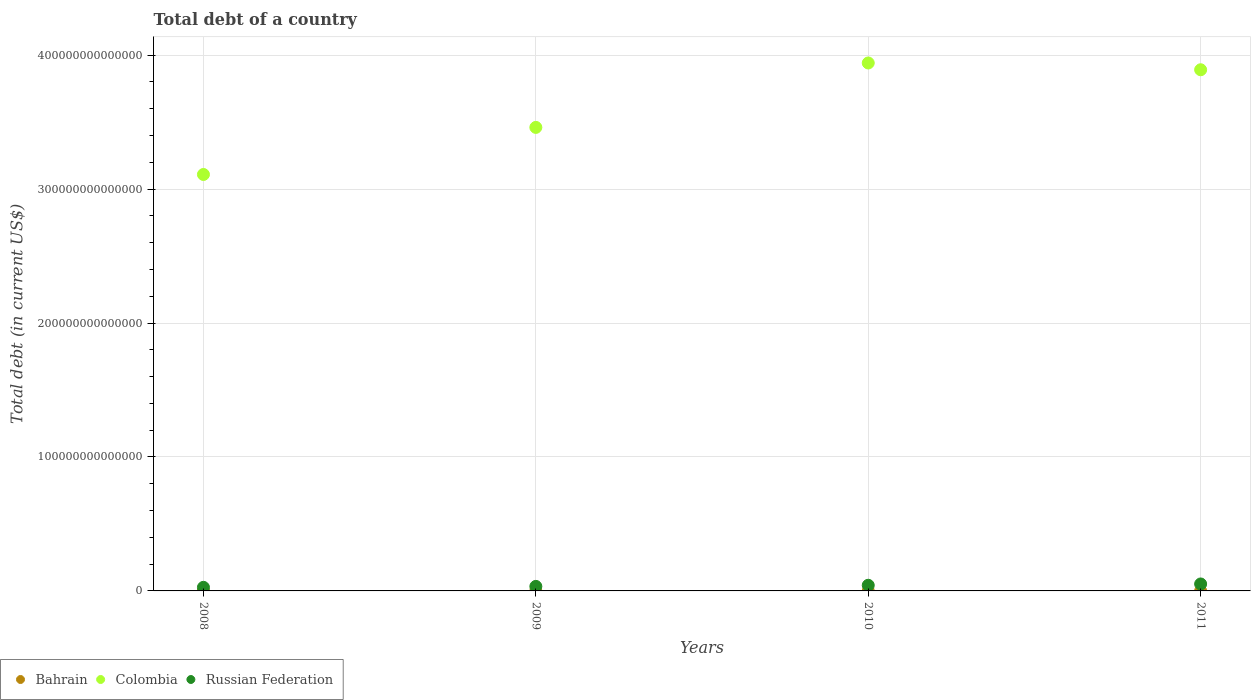How many different coloured dotlines are there?
Your answer should be very brief. 3. What is the debt in Colombia in 2009?
Your response must be concise. 3.46e+14. Across all years, what is the maximum debt in Russian Federation?
Provide a short and direct response. 5.19e+12. Across all years, what is the minimum debt in Colombia?
Provide a succinct answer. 3.11e+14. What is the total debt in Bahrain in the graph?
Your answer should be very brief. 8.87e+09. What is the difference between the debt in Colombia in 2008 and that in 2011?
Your response must be concise. -7.82e+13. What is the difference between the debt in Bahrain in 2011 and the debt in Colombia in 2008?
Provide a short and direct response. -3.11e+14. What is the average debt in Russian Federation per year?
Your response must be concise. 3.87e+12. In the year 2011, what is the difference between the debt in Bahrain and debt in Russian Federation?
Your answer should be compact. -5.19e+12. What is the ratio of the debt in Russian Federation in 2008 to that in 2009?
Ensure brevity in your answer.  0.79. Is the difference between the debt in Bahrain in 2008 and 2009 greater than the difference between the debt in Russian Federation in 2008 and 2009?
Give a very brief answer. Yes. What is the difference between the highest and the second highest debt in Colombia?
Provide a succinct answer. 5.07e+12. What is the difference between the highest and the lowest debt in Bahrain?
Your answer should be very brief. 3.18e+09. In how many years, is the debt in Colombia greater than the average debt in Colombia taken over all years?
Your answer should be compact. 2. Is it the case that in every year, the sum of the debt in Colombia and debt in Bahrain  is greater than the debt in Russian Federation?
Your answer should be very brief. Yes. Does the debt in Russian Federation monotonically increase over the years?
Your answer should be compact. Yes. Is the debt in Russian Federation strictly greater than the debt in Bahrain over the years?
Offer a very short reply. Yes. Is the debt in Bahrain strictly less than the debt in Colombia over the years?
Make the answer very short. Yes. How many dotlines are there?
Provide a succinct answer. 3. How many years are there in the graph?
Offer a very short reply. 4. What is the difference between two consecutive major ticks on the Y-axis?
Your response must be concise. 1.00e+14. Are the values on the major ticks of Y-axis written in scientific E-notation?
Give a very brief answer. No. Does the graph contain grids?
Ensure brevity in your answer.  Yes. How many legend labels are there?
Offer a very short reply. 3. What is the title of the graph?
Make the answer very short. Total debt of a country. Does "Jordan" appear as one of the legend labels in the graph?
Keep it short and to the point. No. What is the label or title of the Y-axis?
Keep it short and to the point. Total debt (in current US$). What is the Total debt (in current US$) in Bahrain in 2008?
Give a very brief answer. 7.05e+08. What is the Total debt (in current US$) in Colombia in 2008?
Provide a succinct answer. 3.11e+14. What is the Total debt (in current US$) of Russian Federation in 2008?
Offer a terse response. 2.68e+12. What is the Total debt (in current US$) of Bahrain in 2009?
Your answer should be very brief. 1.35e+09. What is the Total debt (in current US$) of Colombia in 2009?
Your response must be concise. 3.46e+14. What is the Total debt (in current US$) in Russian Federation in 2009?
Provide a succinct answer. 3.38e+12. What is the Total debt (in current US$) in Bahrain in 2010?
Offer a very short reply. 2.93e+09. What is the Total debt (in current US$) of Colombia in 2010?
Provide a succinct answer. 3.94e+14. What is the Total debt (in current US$) in Russian Federation in 2010?
Offer a terse response. 4.21e+12. What is the Total debt (in current US$) in Bahrain in 2011?
Keep it short and to the point. 3.89e+09. What is the Total debt (in current US$) of Colombia in 2011?
Provide a short and direct response. 3.89e+14. What is the Total debt (in current US$) in Russian Federation in 2011?
Offer a very short reply. 5.19e+12. Across all years, what is the maximum Total debt (in current US$) of Bahrain?
Keep it short and to the point. 3.89e+09. Across all years, what is the maximum Total debt (in current US$) of Colombia?
Offer a very short reply. 3.94e+14. Across all years, what is the maximum Total debt (in current US$) in Russian Federation?
Your response must be concise. 5.19e+12. Across all years, what is the minimum Total debt (in current US$) in Bahrain?
Your response must be concise. 7.05e+08. Across all years, what is the minimum Total debt (in current US$) of Colombia?
Offer a terse response. 3.11e+14. Across all years, what is the minimum Total debt (in current US$) in Russian Federation?
Offer a very short reply. 2.68e+12. What is the total Total debt (in current US$) of Bahrain in the graph?
Give a very brief answer. 8.87e+09. What is the total Total debt (in current US$) of Colombia in the graph?
Your answer should be compact. 1.44e+15. What is the total Total debt (in current US$) in Russian Federation in the graph?
Your answer should be very brief. 1.55e+13. What is the difference between the Total debt (in current US$) of Bahrain in 2008 and that in 2009?
Your answer should be very brief. -6.43e+08. What is the difference between the Total debt (in current US$) in Colombia in 2008 and that in 2009?
Ensure brevity in your answer.  -3.52e+13. What is the difference between the Total debt (in current US$) of Russian Federation in 2008 and that in 2009?
Your answer should be very brief. -6.94e+11. What is the difference between the Total debt (in current US$) of Bahrain in 2008 and that in 2010?
Your answer should be compact. -2.23e+09. What is the difference between the Total debt (in current US$) of Colombia in 2008 and that in 2010?
Offer a terse response. -8.33e+13. What is the difference between the Total debt (in current US$) in Russian Federation in 2008 and that in 2010?
Your answer should be compact. -1.53e+12. What is the difference between the Total debt (in current US$) in Bahrain in 2008 and that in 2011?
Give a very brief answer. -3.18e+09. What is the difference between the Total debt (in current US$) of Colombia in 2008 and that in 2011?
Offer a very short reply. -7.82e+13. What is the difference between the Total debt (in current US$) in Russian Federation in 2008 and that in 2011?
Provide a succinct answer. -2.51e+12. What is the difference between the Total debt (in current US$) of Bahrain in 2009 and that in 2010?
Keep it short and to the point. -1.58e+09. What is the difference between the Total debt (in current US$) in Colombia in 2009 and that in 2010?
Keep it short and to the point. -4.81e+13. What is the difference between the Total debt (in current US$) in Russian Federation in 2009 and that in 2010?
Keep it short and to the point. -8.38e+11. What is the difference between the Total debt (in current US$) in Bahrain in 2009 and that in 2011?
Offer a very short reply. -2.54e+09. What is the difference between the Total debt (in current US$) of Colombia in 2009 and that in 2011?
Offer a very short reply. -4.30e+13. What is the difference between the Total debt (in current US$) of Russian Federation in 2009 and that in 2011?
Your answer should be compact. -1.82e+12. What is the difference between the Total debt (in current US$) of Bahrain in 2010 and that in 2011?
Make the answer very short. -9.58e+08. What is the difference between the Total debt (in current US$) of Colombia in 2010 and that in 2011?
Your answer should be very brief. 5.07e+12. What is the difference between the Total debt (in current US$) of Russian Federation in 2010 and that in 2011?
Provide a short and direct response. -9.81e+11. What is the difference between the Total debt (in current US$) in Bahrain in 2008 and the Total debt (in current US$) in Colombia in 2009?
Provide a succinct answer. -3.46e+14. What is the difference between the Total debt (in current US$) in Bahrain in 2008 and the Total debt (in current US$) in Russian Federation in 2009?
Your answer should be very brief. -3.37e+12. What is the difference between the Total debt (in current US$) of Colombia in 2008 and the Total debt (in current US$) of Russian Federation in 2009?
Your answer should be compact. 3.08e+14. What is the difference between the Total debt (in current US$) of Bahrain in 2008 and the Total debt (in current US$) of Colombia in 2010?
Offer a terse response. -3.94e+14. What is the difference between the Total debt (in current US$) of Bahrain in 2008 and the Total debt (in current US$) of Russian Federation in 2010?
Your response must be concise. -4.21e+12. What is the difference between the Total debt (in current US$) of Colombia in 2008 and the Total debt (in current US$) of Russian Federation in 2010?
Provide a succinct answer. 3.07e+14. What is the difference between the Total debt (in current US$) in Bahrain in 2008 and the Total debt (in current US$) in Colombia in 2011?
Keep it short and to the point. -3.89e+14. What is the difference between the Total debt (in current US$) of Bahrain in 2008 and the Total debt (in current US$) of Russian Federation in 2011?
Give a very brief answer. -5.19e+12. What is the difference between the Total debt (in current US$) in Colombia in 2008 and the Total debt (in current US$) in Russian Federation in 2011?
Provide a short and direct response. 3.06e+14. What is the difference between the Total debt (in current US$) in Bahrain in 2009 and the Total debt (in current US$) in Colombia in 2010?
Your answer should be compact. -3.94e+14. What is the difference between the Total debt (in current US$) of Bahrain in 2009 and the Total debt (in current US$) of Russian Federation in 2010?
Keep it short and to the point. -4.21e+12. What is the difference between the Total debt (in current US$) of Colombia in 2009 and the Total debt (in current US$) of Russian Federation in 2010?
Keep it short and to the point. 3.42e+14. What is the difference between the Total debt (in current US$) of Bahrain in 2009 and the Total debt (in current US$) of Colombia in 2011?
Provide a succinct answer. -3.89e+14. What is the difference between the Total debt (in current US$) of Bahrain in 2009 and the Total debt (in current US$) of Russian Federation in 2011?
Provide a short and direct response. -5.19e+12. What is the difference between the Total debt (in current US$) in Colombia in 2009 and the Total debt (in current US$) in Russian Federation in 2011?
Make the answer very short. 3.41e+14. What is the difference between the Total debt (in current US$) in Bahrain in 2010 and the Total debt (in current US$) in Colombia in 2011?
Provide a succinct answer. -3.89e+14. What is the difference between the Total debt (in current US$) in Bahrain in 2010 and the Total debt (in current US$) in Russian Federation in 2011?
Ensure brevity in your answer.  -5.19e+12. What is the difference between the Total debt (in current US$) of Colombia in 2010 and the Total debt (in current US$) of Russian Federation in 2011?
Keep it short and to the point. 3.89e+14. What is the average Total debt (in current US$) in Bahrain per year?
Your response must be concise. 2.22e+09. What is the average Total debt (in current US$) of Colombia per year?
Provide a short and direct response. 3.60e+14. What is the average Total debt (in current US$) of Russian Federation per year?
Your answer should be very brief. 3.87e+12. In the year 2008, what is the difference between the Total debt (in current US$) of Bahrain and Total debt (in current US$) of Colombia?
Offer a terse response. -3.11e+14. In the year 2008, what is the difference between the Total debt (in current US$) in Bahrain and Total debt (in current US$) in Russian Federation?
Offer a terse response. -2.68e+12. In the year 2008, what is the difference between the Total debt (in current US$) in Colombia and Total debt (in current US$) in Russian Federation?
Your response must be concise. 3.08e+14. In the year 2009, what is the difference between the Total debt (in current US$) of Bahrain and Total debt (in current US$) of Colombia?
Offer a very short reply. -3.46e+14. In the year 2009, what is the difference between the Total debt (in current US$) of Bahrain and Total debt (in current US$) of Russian Federation?
Keep it short and to the point. -3.37e+12. In the year 2009, what is the difference between the Total debt (in current US$) in Colombia and Total debt (in current US$) in Russian Federation?
Give a very brief answer. 3.43e+14. In the year 2010, what is the difference between the Total debt (in current US$) of Bahrain and Total debt (in current US$) of Colombia?
Provide a succinct answer. -3.94e+14. In the year 2010, what is the difference between the Total debt (in current US$) in Bahrain and Total debt (in current US$) in Russian Federation?
Your answer should be very brief. -4.21e+12. In the year 2010, what is the difference between the Total debt (in current US$) in Colombia and Total debt (in current US$) in Russian Federation?
Provide a succinct answer. 3.90e+14. In the year 2011, what is the difference between the Total debt (in current US$) in Bahrain and Total debt (in current US$) in Colombia?
Keep it short and to the point. -3.89e+14. In the year 2011, what is the difference between the Total debt (in current US$) of Bahrain and Total debt (in current US$) of Russian Federation?
Offer a terse response. -5.19e+12. In the year 2011, what is the difference between the Total debt (in current US$) of Colombia and Total debt (in current US$) of Russian Federation?
Offer a very short reply. 3.84e+14. What is the ratio of the Total debt (in current US$) in Bahrain in 2008 to that in 2009?
Offer a terse response. 0.52. What is the ratio of the Total debt (in current US$) of Colombia in 2008 to that in 2009?
Your answer should be compact. 0.9. What is the ratio of the Total debt (in current US$) in Russian Federation in 2008 to that in 2009?
Keep it short and to the point. 0.79. What is the ratio of the Total debt (in current US$) in Bahrain in 2008 to that in 2010?
Provide a short and direct response. 0.24. What is the ratio of the Total debt (in current US$) of Colombia in 2008 to that in 2010?
Provide a succinct answer. 0.79. What is the ratio of the Total debt (in current US$) of Russian Federation in 2008 to that in 2010?
Give a very brief answer. 0.64. What is the ratio of the Total debt (in current US$) of Bahrain in 2008 to that in 2011?
Keep it short and to the point. 0.18. What is the ratio of the Total debt (in current US$) of Colombia in 2008 to that in 2011?
Provide a succinct answer. 0.8. What is the ratio of the Total debt (in current US$) in Russian Federation in 2008 to that in 2011?
Your answer should be very brief. 0.52. What is the ratio of the Total debt (in current US$) of Bahrain in 2009 to that in 2010?
Provide a succinct answer. 0.46. What is the ratio of the Total debt (in current US$) of Colombia in 2009 to that in 2010?
Provide a succinct answer. 0.88. What is the ratio of the Total debt (in current US$) of Russian Federation in 2009 to that in 2010?
Make the answer very short. 0.8. What is the ratio of the Total debt (in current US$) in Bahrain in 2009 to that in 2011?
Your answer should be compact. 0.35. What is the ratio of the Total debt (in current US$) in Colombia in 2009 to that in 2011?
Provide a short and direct response. 0.89. What is the ratio of the Total debt (in current US$) in Russian Federation in 2009 to that in 2011?
Your answer should be compact. 0.65. What is the ratio of the Total debt (in current US$) in Bahrain in 2010 to that in 2011?
Ensure brevity in your answer.  0.75. What is the ratio of the Total debt (in current US$) of Colombia in 2010 to that in 2011?
Offer a very short reply. 1.01. What is the ratio of the Total debt (in current US$) of Russian Federation in 2010 to that in 2011?
Keep it short and to the point. 0.81. What is the difference between the highest and the second highest Total debt (in current US$) of Bahrain?
Offer a terse response. 9.58e+08. What is the difference between the highest and the second highest Total debt (in current US$) of Colombia?
Provide a succinct answer. 5.07e+12. What is the difference between the highest and the second highest Total debt (in current US$) in Russian Federation?
Ensure brevity in your answer.  9.81e+11. What is the difference between the highest and the lowest Total debt (in current US$) of Bahrain?
Offer a very short reply. 3.18e+09. What is the difference between the highest and the lowest Total debt (in current US$) in Colombia?
Offer a terse response. 8.33e+13. What is the difference between the highest and the lowest Total debt (in current US$) of Russian Federation?
Make the answer very short. 2.51e+12. 